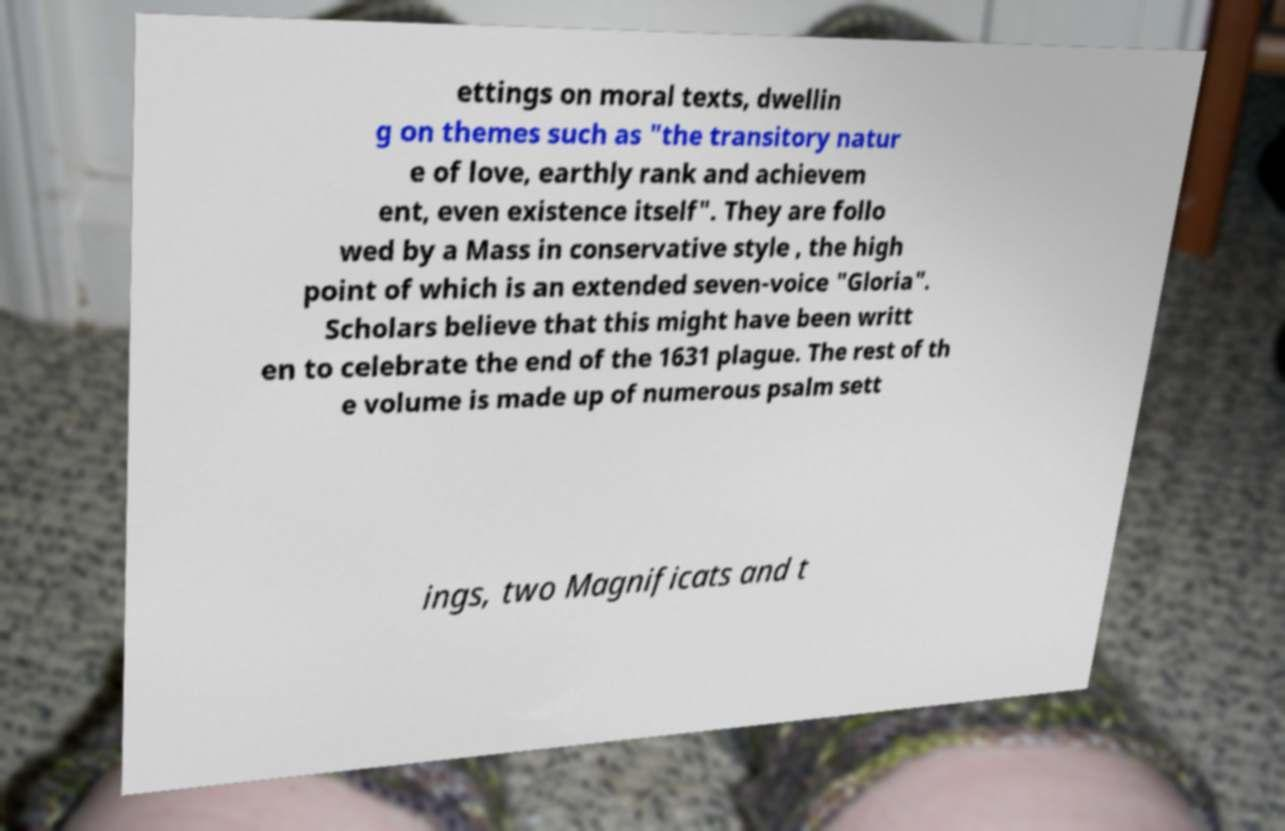Can you read and provide the text displayed in the image?This photo seems to have some interesting text. Can you extract and type it out for me? ettings on moral texts, dwellin g on themes such as "the transitory natur e of love, earthly rank and achievem ent, even existence itself". They are follo wed by a Mass in conservative style , the high point of which is an extended seven-voice "Gloria". Scholars believe that this might have been writt en to celebrate the end of the 1631 plague. The rest of th e volume is made up of numerous psalm sett ings, two Magnificats and t 